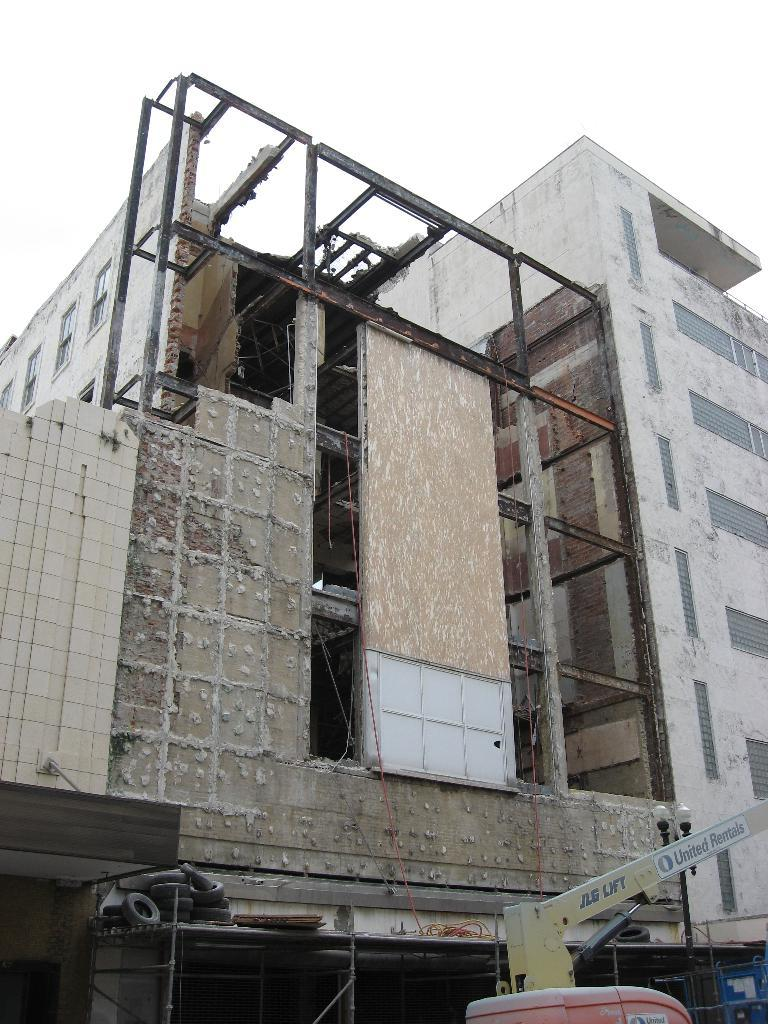What type of view is shown in the image? The image has an outside view. What can be seen in the middle of the image? There is a building in the middle of the image. What is visible at the top of the image? The sky is visible at the top of the image. What leaf is being folded by someone in the image? There is no leaf or person folding a leaf present in the image. What book is being read by someone in the image? There is no book or person reading in the image. 